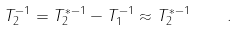Convert formula to latex. <formula><loc_0><loc_0><loc_500><loc_500>T _ { 2 } ^ { - 1 } = T _ { 2 } ^ { \ast - 1 } - T _ { 1 } ^ { - 1 } \approx T _ { 2 } ^ { \ast - 1 } \quad .</formula> 